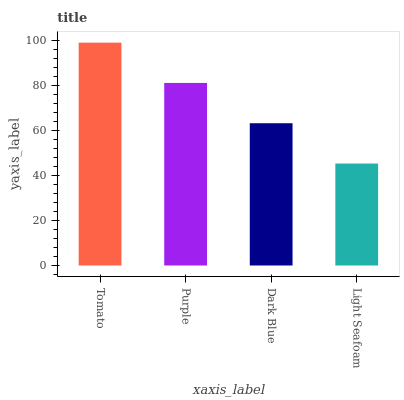Is Light Seafoam the minimum?
Answer yes or no. Yes. Is Tomato the maximum?
Answer yes or no. Yes. Is Purple the minimum?
Answer yes or no. No. Is Purple the maximum?
Answer yes or no. No. Is Tomato greater than Purple?
Answer yes or no. Yes. Is Purple less than Tomato?
Answer yes or no. Yes. Is Purple greater than Tomato?
Answer yes or no. No. Is Tomato less than Purple?
Answer yes or no. No. Is Purple the high median?
Answer yes or no. Yes. Is Dark Blue the low median?
Answer yes or no. Yes. Is Tomato the high median?
Answer yes or no. No. Is Purple the low median?
Answer yes or no. No. 